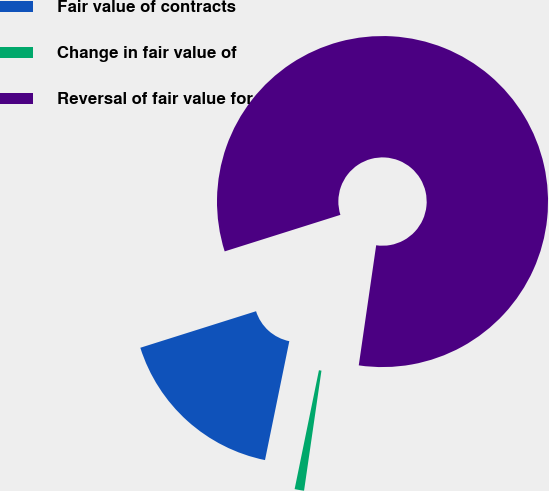Convert chart. <chart><loc_0><loc_0><loc_500><loc_500><pie_chart><fcel>Fair value of contracts<fcel>Change in fair value of<fcel>Reversal of fair value for<nl><fcel>16.92%<fcel>0.92%<fcel>82.15%<nl></chart> 